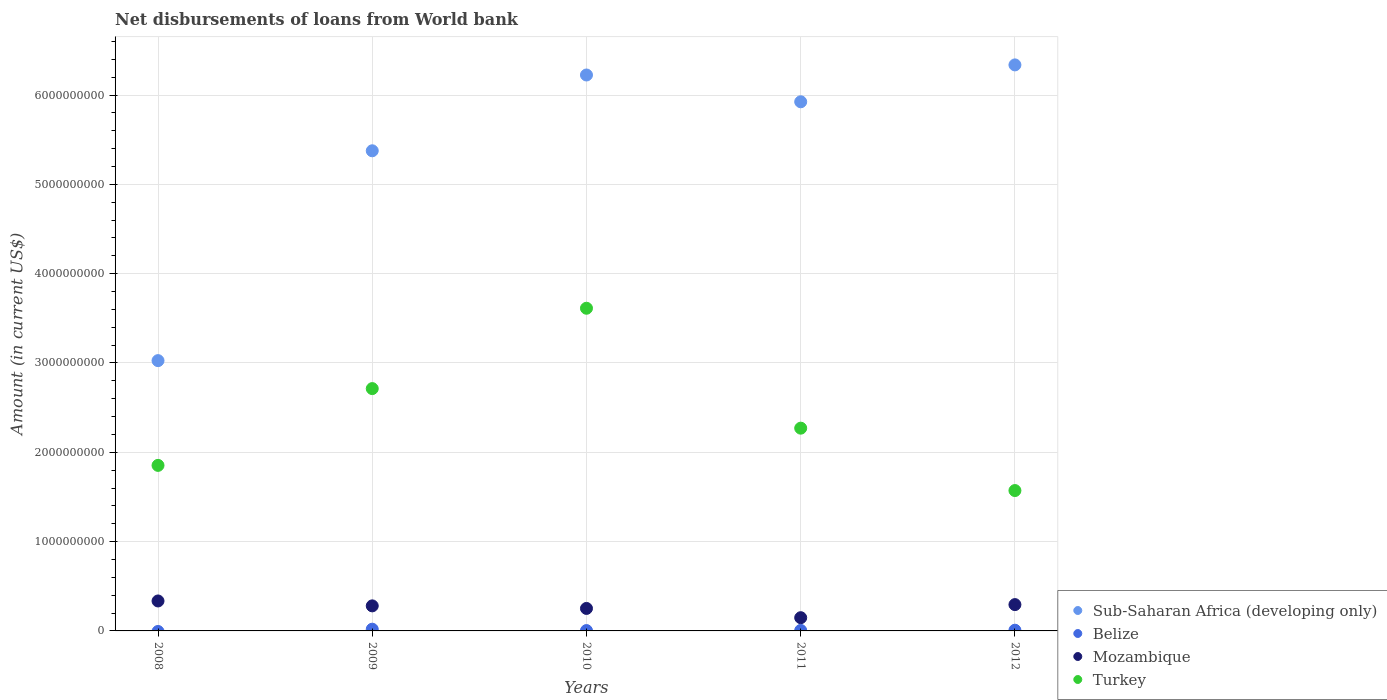How many different coloured dotlines are there?
Ensure brevity in your answer.  4. What is the amount of loan disbursed from World Bank in Turkey in 2012?
Your answer should be very brief. 1.57e+09. Across all years, what is the maximum amount of loan disbursed from World Bank in Belize?
Offer a terse response. 1.93e+07. Across all years, what is the minimum amount of loan disbursed from World Bank in Mozambique?
Provide a short and direct response. 1.48e+08. In which year was the amount of loan disbursed from World Bank in Turkey maximum?
Give a very brief answer. 2010. What is the total amount of loan disbursed from World Bank in Belize in the graph?
Your response must be concise. 3.68e+07. What is the difference between the amount of loan disbursed from World Bank in Mozambique in 2011 and that in 2012?
Keep it short and to the point. -1.47e+08. What is the difference between the amount of loan disbursed from World Bank in Turkey in 2011 and the amount of loan disbursed from World Bank in Mozambique in 2010?
Make the answer very short. 2.02e+09. What is the average amount of loan disbursed from World Bank in Turkey per year?
Make the answer very short. 2.40e+09. In the year 2010, what is the difference between the amount of loan disbursed from World Bank in Mozambique and amount of loan disbursed from World Bank in Sub-Saharan Africa (developing only)?
Provide a succinct answer. -5.97e+09. In how many years, is the amount of loan disbursed from World Bank in Turkey greater than 6000000000 US$?
Your answer should be compact. 0. What is the ratio of the amount of loan disbursed from World Bank in Turkey in 2010 to that in 2011?
Ensure brevity in your answer.  1.59. Is the difference between the amount of loan disbursed from World Bank in Mozambique in 2011 and 2012 greater than the difference between the amount of loan disbursed from World Bank in Sub-Saharan Africa (developing only) in 2011 and 2012?
Keep it short and to the point. Yes. What is the difference between the highest and the second highest amount of loan disbursed from World Bank in Sub-Saharan Africa (developing only)?
Ensure brevity in your answer.  1.13e+08. What is the difference between the highest and the lowest amount of loan disbursed from World Bank in Mozambique?
Offer a terse response. 1.87e+08. Is the sum of the amount of loan disbursed from World Bank in Sub-Saharan Africa (developing only) in 2008 and 2011 greater than the maximum amount of loan disbursed from World Bank in Mozambique across all years?
Give a very brief answer. Yes. Is it the case that in every year, the sum of the amount of loan disbursed from World Bank in Belize and amount of loan disbursed from World Bank in Sub-Saharan Africa (developing only)  is greater than the sum of amount of loan disbursed from World Bank in Mozambique and amount of loan disbursed from World Bank in Turkey?
Offer a very short reply. No. Is it the case that in every year, the sum of the amount of loan disbursed from World Bank in Turkey and amount of loan disbursed from World Bank in Belize  is greater than the amount of loan disbursed from World Bank in Sub-Saharan Africa (developing only)?
Give a very brief answer. No. Does the amount of loan disbursed from World Bank in Sub-Saharan Africa (developing only) monotonically increase over the years?
Give a very brief answer. No. Is the amount of loan disbursed from World Bank in Mozambique strictly greater than the amount of loan disbursed from World Bank in Turkey over the years?
Your answer should be compact. No. Is the amount of loan disbursed from World Bank in Belize strictly less than the amount of loan disbursed from World Bank in Turkey over the years?
Ensure brevity in your answer.  Yes. How many dotlines are there?
Provide a short and direct response. 4. Does the graph contain any zero values?
Offer a terse response. Yes. Where does the legend appear in the graph?
Make the answer very short. Bottom right. What is the title of the graph?
Your answer should be compact. Net disbursements of loans from World bank. What is the label or title of the X-axis?
Your answer should be very brief. Years. What is the label or title of the Y-axis?
Your response must be concise. Amount (in current US$). What is the Amount (in current US$) of Sub-Saharan Africa (developing only) in 2008?
Offer a terse response. 3.03e+09. What is the Amount (in current US$) of Belize in 2008?
Your answer should be compact. 0. What is the Amount (in current US$) in Mozambique in 2008?
Your answer should be very brief. 3.35e+08. What is the Amount (in current US$) of Turkey in 2008?
Provide a succinct answer. 1.85e+09. What is the Amount (in current US$) of Sub-Saharan Africa (developing only) in 2009?
Ensure brevity in your answer.  5.38e+09. What is the Amount (in current US$) of Belize in 2009?
Make the answer very short. 1.93e+07. What is the Amount (in current US$) in Mozambique in 2009?
Offer a terse response. 2.80e+08. What is the Amount (in current US$) of Turkey in 2009?
Provide a short and direct response. 2.71e+09. What is the Amount (in current US$) of Sub-Saharan Africa (developing only) in 2010?
Provide a succinct answer. 6.22e+09. What is the Amount (in current US$) in Belize in 2010?
Ensure brevity in your answer.  3.92e+06. What is the Amount (in current US$) of Mozambique in 2010?
Your answer should be very brief. 2.52e+08. What is the Amount (in current US$) in Turkey in 2010?
Provide a short and direct response. 3.61e+09. What is the Amount (in current US$) of Sub-Saharan Africa (developing only) in 2011?
Provide a succinct answer. 5.92e+09. What is the Amount (in current US$) of Belize in 2011?
Give a very brief answer. 5.65e+06. What is the Amount (in current US$) in Mozambique in 2011?
Provide a short and direct response. 1.48e+08. What is the Amount (in current US$) of Turkey in 2011?
Provide a short and direct response. 2.27e+09. What is the Amount (in current US$) in Sub-Saharan Africa (developing only) in 2012?
Your response must be concise. 6.34e+09. What is the Amount (in current US$) in Belize in 2012?
Ensure brevity in your answer.  7.91e+06. What is the Amount (in current US$) in Mozambique in 2012?
Give a very brief answer. 2.95e+08. What is the Amount (in current US$) in Turkey in 2012?
Offer a terse response. 1.57e+09. Across all years, what is the maximum Amount (in current US$) in Sub-Saharan Africa (developing only)?
Offer a terse response. 6.34e+09. Across all years, what is the maximum Amount (in current US$) of Belize?
Your answer should be compact. 1.93e+07. Across all years, what is the maximum Amount (in current US$) of Mozambique?
Make the answer very short. 3.35e+08. Across all years, what is the maximum Amount (in current US$) in Turkey?
Keep it short and to the point. 3.61e+09. Across all years, what is the minimum Amount (in current US$) in Sub-Saharan Africa (developing only)?
Make the answer very short. 3.03e+09. Across all years, what is the minimum Amount (in current US$) of Belize?
Provide a succinct answer. 0. Across all years, what is the minimum Amount (in current US$) of Mozambique?
Your answer should be very brief. 1.48e+08. Across all years, what is the minimum Amount (in current US$) of Turkey?
Your response must be concise. 1.57e+09. What is the total Amount (in current US$) of Sub-Saharan Africa (developing only) in the graph?
Give a very brief answer. 2.69e+1. What is the total Amount (in current US$) in Belize in the graph?
Keep it short and to the point. 3.68e+07. What is the total Amount (in current US$) in Mozambique in the graph?
Make the answer very short. 1.31e+09. What is the total Amount (in current US$) of Turkey in the graph?
Offer a terse response. 1.20e+1. What is the difference between the Amount (in current US$) in Sub-Saharan Africa (developing only) in 2008 and that in 2009?
Keep it short and to the point. -2.35e+09. What is the difference between the Amount (in current US$) in Mozambique in 2008 and that in 2009?
Provide a short and direct response. 5.49e+07. What is the difference between the Amount (in current US$) in Turkey in 2008 and that in 2009?
Your answer should be very brief. -8.60e+08. What is the difference between the Amount (in current US$) in Sub-Saharan Africa (developing only) in 2008 and that in 2010?
Keep it short and to the point. -3.20e+09. What is the difference between the Amount (in current US$) in Mozambique in 2008 and that in 2010?
Your response must be concise. 8.36e+07. What is the difference between the Amount (in current US$) in Turkey in 2008 and that in 2010?
Make the answer very short. -1.76e+09. What is the difference between the Amount (in current US$) of Sub-Saharan Africa (developing only) in 2008 and that in 2011?
Give a very brief answer. -2.90e+09. What is the difference between the Amount (in current US$) in Mozambique in 2008 and that in 2011?
Provide a succinct answer. 1.87e+08. What is the difference between the Amount (in current US$) of Turkey in 2008 and that in 2011?
Offer a terse response. -4.17e+08. What is the difference between the Amount (in current US$) in Sub-Saharan Africa (developing only) in 2008 and that in 2012?
Your answer should be compact. -3.31e+09. What is the difference between the Amount (in current US$) in Mozambique in 2008 and that in 2012?
Offer a terse response. 4.08e+07. What is the difference between the Amount (in current US$) of Turkey in 2008 and that in 2012?
Keep it short and to the point. 2.82e+08. What is the difference between the Amount (in current US$) in Sub-Saharan Africa (developing only) in 2009 and that in 2010?
Your answer should be compact. -8.49e+08. What is the difference between the Amount (in current US$) of Belize in 2009 and that in 2010?
Make the answer very short. 1.54e+07. What is the difference between the Amount (in current US$) of Mozambique in 2009 and that in 2010?
Ensure brevity in your answer.  2.87e+07. What is the difference between the Amount (in current US$) of Turkey in 2009 and that in 2010?
Offer a very short reply. -9.00e+08. What is the difference between the Amount (in current US$) of Sub-Saharan Africa (developing only) in 2009 and that in 2011?
Make the answer very short. -5.49e+08. What is the difference between the Amount (in current US$) in Belize in 2009 and that in 2011?
Offer a very short reply. 1.37e+07. What is the difference between the Amount (in current US$) of Mozambique in 2009 and that in 2011?
Make the answer very short. 1.32e+08. What is the difference between the Amount (in current US$) of Turkey in 2009 and that in 2011?
Offer a very short reply. 4.43e+08. What is the difference between the Amount (in current US$) of Sub-Saharan Africa (developing only) in 2009 and that in 2012?
Offer a very short reply. -9.62e+08. What is the difference between the Amount (in current US$) of Belize in 2009 and that in 2012?
Make the answer very short. 1.14e+07. What is the difference between the Amount (in current US$) in Mozambique in 2009 and that in 2012?
Ensure brevity in your answer.  -1.42e+07. What is the difference between the Amount (in current US$) in Turkey in 2009 and that in 2012?
Keep it short and to the point. 1.14e+09. What is the difference between the Amount (in current US$) of Sub-Saharan Africa (developing only) in 2010 and that in 2011?
Your answer should be very brief. 3.00e+08. What is the difference between the Amount (in current US$) of Belize in 2010 and that in 2011?
Make the answer very short. -1.73e+06. What is the difference between the Amount (in current US$) of Mozambique in 2010 and that in 2011?
Offer a terse response. 1.04e+08. What is the difference between the Amount (in current US$) in Turkey in 2010 and that in 2011?
Your answer should be very brief. 1.34e+09. What is the difference between the Amount (in current US$) of Sub-Saharan Africa (developing only) in 2010 and that in 2012?
Offer a terse response. -1.13e+08. What is the difference between the Amount (in current US$) in Belize in 2010 and that in 2012?
Ensure brevity in your answer.  -3.98e+06. What is the difference between the Amount (in current US$) of Mozambique in 2010 and that in 2012?
Provide a succinct answer. -4.29e+07. What is the difference between the Amount (in current US$) in Turkey in 2010 and that in 2012?
Provide a short and direct response. 2.04e+09. What is the difference between the Amount (in current US$) in Sub-Saharan Africa (developing only) in 2011 and that in 2012?
Your response must be concise. -4.13e+08. What is the difference between the Amount (in current US$) of Belize in 2011 and that in 2012?
Provide a succinct answer. -2.26e+06. What is the difference between the Amount (in current US$) of Mozambique in 2011 and that in 2012?
Your answer should be compact. -1.47e+08. What is the difference between the Amount (in current US$) in Turkey in 2011 and that in 2012?
Offer a very short reply. 6.99e+08. What is the difference between the Amount (in current US$) in Sub-Saharan Africa (developing only) in 2008 and the Amount (in current US$) in Belize in 2009?
Your response must be concise. 3.01e+09. What is the difference between the Amount (in current US$) of Sub-Saharan Africa (developing only) in 2008 and the Amount (in current US$) of Mozambique in 2009?
Provide a short and direct response. 2.75e+09. What is the difference between the Amount (in current US$) of Sub-Saharan Africa (developing only) in 2008 and the Amount (in current US$) of Turkey in 2009?
Your response must be concise. 3.13e+08. What is the difference between the Amount (in current US$) in Mozambique in 2008 and the Amount (in current US$) in Turkey in 2009?
Provide a succinct answer. -2.38e+09. What is the difference between the Amount (in current US$) in Sub-Saharan Africa (developing only) in 2008 and the Amount (in current US$) in Belize in 2010?
Keep it short and to the point. 3.02e+09. What is the difference between the Amount (in current US$) of Sub-Saharan Africa (developing only) in 2008 and the Amount (in current US$) of Mozambique in 2010?
Your response must be concise. 2.77e+09. What is the difference between the Amount (in current US$) of Sub-Saharan Africa (developing only) in 2008 and the Amount (in current US$) of Turkey in 2010?
Keep it short and to the point. -5.86e+08. What is the difference between the Amount (in current US$) of Mozambique in 2008 and the Amount (in current US$) of Turkey in 2010?
Your answer should be very brief. -3.28e+09. What is the difference between the Amount (in current US$) in Sub-Saharan Africa (developing only) in 2008 and the Amount (in current US$) in Belize in 2011?
Your answer should be very brief. 3.02e+09. What is the difference between the Amount (in current US$) in Sub-Saharan Africa (developing only) in 2008 and the Amount (in current US$) in Mozambique in 2011?
Ensure brevity in your answer.  2.88e+09. What is the difference between the Amount (in current US$) of Sub-Saharan Africa (developing only) in 2008 and the Amount (in current US$) of Turkey in 2011?
Your response must be concise. 7.56e+08. What is the difference between the Amount (in current US$) of Mozambique in 2008 and the Amount (in current US$) of Turkey in 2011?
Keep it short and to the point. -1.93e+09. What is the difference between the Amount (in current US$) of Sub-Saharan Africa (developing only) in 2008 and the Amount (in current US$) of Belize in 2012?
Make the answer very short. 3.02e+09. What is the difference between the Amount (in current US$) of Sub-Saharan Africa (developing only) in 2008 and the Amount (in current US$) of Mozambique in 2012?
Ensure brevity in your answer.  2.73e+09. What is the difference between the Amount (in current US$) of Sub-Saharan Africa (developing only) in 2008 and the Amount (in current US$) of Turkey in 2012?
Provide a short and direct response. 1.45e+09. What is the difference between the Amount (in current US$) of Mozambique in 2008 and the Amount (in current US$) of Turkey in 2012?
Your answer should be very brief. -1.24e+09. What is the difference between the Amount (in current US$) of Sub-Saharan Africa (developing only) in 2009 and the Amount (in current US$) of Belize in 2010?
Your response must be concise. 5.37e+09. What is the difference between the Amount (in current US$) in Sub-Saharan Africa (developing only) in 2009 and the Amount (in current US$) in Mozambique in 2010?
Your response must be concise. 5.12e+09. What is the difference between the Amount (in current US$) of Sub-Saharan Africa (developing only) in 2009 and the Amount (in current US$) of Turkey in 2010?
Offer a terse response. 1.76e+09. What is the difference between the Amount (in current US$) in Belize in 2009 and the Amount (in current US$) in Mozambique in 2010?
Keep it short and to the point. -2.32e+08. What is the difference between the Amount (in current US$) in Belize in 2009 and the Amount (in current US$) in Turkey in 2010?
Your response must be concise. -3.59e+09. What is the difference between the Amount (in current US$) of Mozambique in 2009 and the Amount (in current US$) of Turkey in 2010?
Offer a very short reply. -3.33e+09. What is the difference between the Amount (in current US$) in Sub-Saharan Africa (developing only) in 2009 and the Amount (in current US$) in Belize in 2011?
Your answer should be compact. 5.37e+09. What is the difference between the Amount (in current US$) in Sub-Saharan Africa (developing only) in 2009 and the Amount (in current US$) in Mozambique in 2011?
Provide a short and direct response. 5.23e+09. What is the difference between the Amount (in current US$) in Sub-Saharan Africa (developing only) in 2009 and the Amount (in current US$) in Turkey in 2011?
Give a very brief answer. 3.11e+09. What is the difference between the Amount (in current US$) of Belize in 2009 and the Amount (in current US$) of Mozambique in 2011?
Offer a very short reply. -1.29e+08. What is the difference between the Amount (in current US$) in Belize in 2009 and the Amount (in current US$) in Turkey in 2011?
Make the answer very short. -2.25e+09. What is the difference between the Amount (in current US$) of Mozambique in 2009 and the Amount (in current US$) of Turkey in 2011?
Offer a terse response. -1.99e+09. What is the difference between the Amount (in current US$) in Sub-Saharan Africa (developing only) in 2009 and the Amount (in current US$) in Belize in 2012?
Provide a succinct answer. 5.37e+09. What is the difference between the Amount (in current US$) of Sub-Saharan Africa (developing only) in 2009 and the Amount (in current US$) of Mozambique in 2012?
Your response must be concise. 5.08e+09. What is the difference between the Amount (in current US$) of Sub-Saharan Africa (developing only) in 2009 and the Amount (in current US$) of Turkey in 2012?
Provide a succinct answer. 3.80e+09. What is the difference between the Amount (in current US$) of Belize in 2009 and the Amount (in current US$) of Mozambique in 2012?
Keep it short and to the point. -2.75e+08. What is the difference between the Amount (in current US$) in Belize in 2009 and the Amount (in current US$) in Turkey in 2012?
Give a very brief answer. -1.55e+09. What is the difference between the Amount (in current US$) in Mozambique in 2009 and the Amount (in current US$) in Turkey in 2012?
Provide a short and direct response. -1.29e+09. What is the difference between the Amount (in current US$) in Sub-Saharan Africa (developing only) in 2010 and the Amount (in current US$) in Belize in 2011?
Your response must be concise. 6.22e+09. What is the difference between the Amount (in current US$) of Sub-Saharan Africa (developing only) in 2010 and the Amount (in current US$) of Mozambique in 2011?
Your answer should be compact. 6.08e+09. What is the difference between the Amount (in current US$) in Sub-Saharan Africa (developing only) in 2010 and the Amount (in current US$) in Turkey in 2011?
Make the answer very short. 3.95e+09. What is the difference between the Amount (in current US$) of Belize in 2010 and the Amount (in current US$) of Mozambique in 2011?
Provide a succinct answer. -1.44e+08. What is the difference between the Amount (in current US$) in Belize in 2010 and the Amount (in current US$) in Turkey in 2011?
Give a very brief answer. -2.27e+09. What is the difference between the Amount (in current US$) in Mozambique in 2010 and the Amount (in current US$) in Turkey in 2011?
Offer a terse response. -2.02e+09. What is the difference between the Amount (in current US$) in Sub-Saharan Africa (developing only) in 2010 and the Amount (in current US$) in Belize in 2012?
Your response must be concise. 6.22e+09. What is the difference between the Amount (in current US$) in Sub-Saharan Africa (developing only) in 2010 and the Amount (in current US$) in Mozambique in 2012?
Offer a terse response. 5.93e+09. What is the difference between the Amount (in current US$) in Sub-Saharan Africa (developing only) in 2010 and the Amount (in current US$) in Turkey in 2012?
Offer a terse response. 4.65e+09. What is the difference between the Amount (in current US$) in Belize in 2010 and the Amount (in current US$) in Mozambique in 2012?
Ensure brevity in your answer.  -2.91e+08. What is the difference between the Amount (in current US$) in Belize in 2010 and the Amount (in current US$) in Turkey in 2012?
Give a very brief answer. -1.57e+09. What is the difference between the Amount (in current US$) in Mozambique in 2010 and the Amount (in current US$) in Turkey in 2012?
Provide a short and direct response. -1.32e+09. What is the difference between the Amount (in current US$) of Sub-Saharan Africa (developing only) in 2011 and the Amount (in current US$) of Belize in 2012?
Give a very brief answer. 5.92e+09. What is the difference between the Amount (in current US$) of Sub-Saharan Africa (developing only) in 2011 and the Amount (in current US$) of Mozambique in 2012?
Offer a terse response. 5.63e+09. What is the difference between the Amount (in current US$) of Sub-Saharan Africa (developing only) in 2011 and the Amount (in current US$) of Turkey in 2012?
Provide a succinct answer. 4.35e+09. What is the difference between the Amount (in current US$) in Belize in 2011 and the Amount (in current US$) in Mozambique in 2012?
Keep it short and to the point. -2.89e+08. What is the difference between the Amount (in current US$) of Belize in 2011 and the Amount (in current US$) of Turkey in 2012?
Your response must be concise. -1.57e+09. What is the difference between the Amount (in current US$) in Mozambique in 2011 and the Amount (in current US$) in Turkey in 2012?
Provide a short and direct response. -1.42e+09. What is the average Amount (in current US$) of Sub-Saharan Africa (developing only) per year?
Your answer should be very brief. 5.38e+09. What is the average Amount (in current US$) of Belize per year?
Your response must be concise. 7.36e+06. What is the average Amount (in current US$) of Mozambique per year?
Ensure brevity in your answer.  2.62e+08. What is the average Amount (in current US$) of Turkey per year?
Provide a short and direct response. 2.40e+09. In the year 2008, what is the difference between the Amount (in current US$) in Sub-Saharan Africa (developing only) and Amount (in current US$) in Mozambique?
Your response must be concise. 2.69e+09. In the year 2008, what is the difference between the Amount (in current US$) of Sub-Saharan Africa (developing only) and Amount (in current US$) of Turkey?
Provide a succinct answer. 1.17e+09. In the year 2008, what is the difference between the Amount (in current US$) in Mozambique and Amount (in current US$) in Turkey?
Ensure brevity in your answer.  -1.52e+09. In the year 2009, what is the difference between the Amount (in current US$) in Sub-Saharan Africa (developing only) and Amount (in current US$) in Belize?
Your response must be concise. 5.36e+09. In the year 2009, what is the difference between the Amount (in current US$) in Sub-Saharan Africa (developing only) and Amount (in current US$) in Mozambique?
Keep it short and to the point. 5.10e+09. In the year 2009, what is the difference between the Amount (in current US$) in Sub-Saharan Africa (developing only) and Amount (in current US$) in Turkey?
Your answer should be very brief. 2.66e+09. In the year 2009, what is the difference between the Amount (in current US$) of Belize and Amount (in current US$) of Mozambique?
Ensure brevity in your answer.  -2.61e+08. In the year 2009, what is the difference between the Amount (in current US$) of Belize and Amount (in current US$) of Turkey?
Provide a succinct answer. -2.69e+09. In the year 2009, what is the difference between the Amount (in current US$) in Mozambique and Amount (in current US$) in Turkey?
Make the answer very short. -2.43e+09. In the year 2010, what is the difference between the Amount (in current US$) in Sub-Saharan Africa (developing only) and Amount (in current US$) in Belize?
Your answer should be compact. 6.22e+09. In the year 2010, what is the difference between the Amount (in current US$) of Sub-Saharan Africa (developing only) and Amount (in current US$) of Mozambique?
Your answer should be compact. 5.97e+09. In the year 2010, what is the difference between the Amount (in current US$) of Sub-Saharan Africa (developing only) and Amount (in current US$) of Turkey?
Provide a short and direct response. 2.61e+09. In the year 2010, what is the difference between the Amount (in current US$) in Belize and Amount (in current US$) in Mozambique?
Ensure brevity in your answer.  -2.48e+08. In the year 2010, what is the difference between the Amount (in current US$) of Belize and Amount (in current US$) of Turkey?
Your response must be concise. -3.61e+09. In the year 2010, what is the difference between the Amount (in current US$) in Mozambique and Amount (in current US$) in Turkey?
Your response must be concise. -3.36e+09. In the year 2011, what is the difference between the Amount (in current US$) of Sub-Saharan Africa (developing only) and Amount (in current US$) of Belize?
Your response must be concise. 5.92e+09. In the year 2011, what is the difference between the Amount (in current US$) in Sub-Saharan Africa (developing only) and Amount (in current US$) in Mozambique?
Your answer should be very brief. 5.78e+09. In the year 2011, what is the difference between the Amount (in current US$) in Sub-Saharan Africa (developing only) and Amount (in current US$) in Turkey?
Your answer should be very brief. 3.65e+09. In the year 2011, what is the difference between the Amount (in current US$) of Belize and Amount (in current US$) of Mozambique?
Offer a terse response. -1.42e+08. In the year 2011, what is the difference between the Amount (in current US$) of Belize and Amount (in current US$) of Turkey?
Ensure brevity in your answer.  -2.26e+09. In the year 2011, what is the difference between the Amount (in current US$) in Mozambique and Amount (in current US$) in Turkey?
Offer a very short reply. -2.12e+09. In the year 2012, what is the difference between the Amount (in current US$) in Sub-Saharan Africa (developing only) and Amount (in current US$) in Belize?
Your response must be concise. 6.33e+09. In the year 2012, what is the difference between the Amount (in current US$) of Sub-Saharan Africa (developing only) and Amount (in current US$) of Mozambique?
Your answer should be compact. 6.04e+09. In the year 2012, what is the difference between the Amount (in current US$) of Sub-Saharan Africa (developing only) and Amount (in current US$) of Turkey?
Offer a terse response. 4.77e+09. In the year 2012, what is the difference between the Amount (in current US$) of Belize and Amount (in current US$) of Mozambique?
Give a very brief answer. -2.87e+08. In the year 2012, what is the difference between the Amount (in current US$) of Belize and Amount (in current US$) of Turkey?
Keep it short and to the point. -1.56e+09. In the year 2012, what is the difference between the Amount (in current US$) of Mozambique and Amount (in current US$) of Turkey?
Offer a very short reply. -1.28e+09. What is the ratio of the Amount (in current US$) in Sub-Saharan Africa (developing only) in 2008 to that in 2009?
Make the answer very short. 0.56. What is the ratio of the Amount (in current US$) in Mozambique in 2008 to that in 2009?
Make the answer very short. 1.2. What is the ratio of the Amount (in current US$) of Turkey in 2008 to that in 2009?
Provide a succinct answer. 0.68. What is the ratio of the Amount (in current US$) in Sub-Saharan Africa (developing only) in 2008 to that in 2010?
Offer a terse response. 0.49. What is the ratio of the Amount (in current US$) of Mozambique in 2008 to that in 2010?
Your answer should be very brief. 1.33. What is the ratio of the Amount (in current US$) of Turkey in 2008 to that in 2010?
Keep it short and to the point. 0.51. What is the ratio of the Amount (in current US$) of Sub-Saharan Africa (developing only) in 2008 to that in 2011?
Ensure brevity in your answer.  0.51. What is the ratio of the Amount (in current US$) in Mozambique in 2008 to that in 2011?
Provide a succinct answer. 2.27. What is the ratio of the Amount (in current US$) of Turkey in 2008 to that in 2011?
Provide a succinct answer. 0.82. What is the ratio of the Amount (in current US$) in Sub-Saharan Africa (developing only) in 2008 to that in 2012?
Ensure brevity in your answer.  0.48. What is the ratio of the Amount (in current US$) in Mozambique in 2008 to that in 2012?
Your response must be concise. 1.14. What is the ratio of the Amount (in current US$) in Turkey in 2008 to that in 2012?
Give a very brief answer. 1.18. What is the ratio of the Amount (in current US$) of Sub-Saharan Africa (developing only) in 2009 to that in 2010?
Provide a short and direct response. 0.86. What is the ratio of the Amount (in current US$) of Belize in 2009 to that in 2010?
Your answer should be very brief. 4.92. What is the ratio of the Amount (in current US$) of Mozambique in 2009 to that in 2010?
Provide a short and direct response. 1.11. What is the ratio of the Amount (in current US$) in Turkey in 2009 to that in 2010?
Your answer should be very brief. 0.75. What is the ratio of the Amount (in current US$) of Sub-Saharan Africa (developing only) in 2009 to that in 2011?
Provide a short and direct response. 0.91. What is the ratio of the Amount (in current US$) of Belize in 2009 to that in 2011?
Provide a short and direct response. 3.42. What is the ratio of the Amount (in current US$) of Mozambique in 2009 to that in 2011?
Offer a very short reply. 1.89. What is the ratio of the Amount (in current US$) of Turkey in 2009 to that in 2011?
Your response must be concise. 1.2. What is the ratio of the Amount (in current US$) of Sub-Saharan Africa (developing only) in 2009 to that in 2012?
Offer a very short reply. 0.85. What is the ratio of the Amount (in current US$) of Belize in 2009 to that in 2012?
Make the answer very short. 2.44. What is the ratio of the Amount (in current US$) in Mozambique in 2009 to that in 2012?
Offer a very short reply. 0.95. What is the ratio of the Amount (in current US$) of Turkey in 2009 to that in 2012?
Your response must be concise. 1.73. What is the ratio of the Amount (in current US$) of Sub-Saharan Africa (developing only) in 2010 to that in 2011?
Offer a very short reply. 1.05. What is the ratio of the Amount (in current US$) of Belize in 2010 to that in 2011?
Give a very brief answer. 0.69. What is the ratio of the Amount (in current US$) of Mozambique in 2010 to that in 2011?
Ensure brevity in your answer.  1.7. What is the ratio of the Amount (in current US$) in Turkey in 2010 to that in 2011?
Your answer should be compact. 1.59. What is the ratio of the Amount (in current US$) in Sub-Saharan Africa (developing only) in 2010 to that in 2012?
Your answer should be compact. 0.98. What is the ratio of the Amount (in current US$) of Belize in 2010 to that in 2012?
Give a very brief answer. 0.5. What is the ratio of the Amount (in current US$) of Mozambique in 2010 to that in 2012?
Make the answer very short. 0.85. What is the ratio of the Amount (in current US$) of Turkey in 2010 to that in 2012?
Your response must be concise. 2.3. What is the ratio of the Amount (in current US$) of Sub-Saharan Africa (developing only) in 2011 to that in 2012?
Give a very brief answer. 0.93. What is the ratio of the Amount (in current US$) of Belize in 2011 to that in 2012?
Provide a succinct answer. 0.71. What is the ratio of the Amount (in current US$) of Mozambique in 2011 to that in 2012?
Make the answer very short. 0.5. What is the ratio of the Amount (in current US$) in Turkey in 2011 to that in 2012?
Your response must be concise. 1.44. What is the difference between the highest and the second highest Amount (in current US$) of Sub-Saharan Africa (developing only)?
Your answer should be compact. 1.13e+08. What is the difference between the highest and the second highest Amount (in current US$) of Belize?
Offer a terse response. 1.14e+07. What is the difference between the highest and the second highest Amount (in current US$) in Mozambique?
Keep it short and to the point. 4.08e+07. What is the difference between the highest and the second highest Amount (in current US$) of Turkey?
Your response must be concise. 9.00e+08. What is the difference between the highest and the lowest Amount (in current US$) of Sub-Saharan Africa (developing only)?
Ensure brevity in your answer.  3.31e+09. What is the difference between the highest and the lowest Amount (in current US$) in Belize?
Offer a terse response. 1.93e+07. What is the difference between the highest and the lowest Amount (in current US$) in Mozambique?
Your answer should be compact. 1.87e+08. What is the difference between the highest and the lowest Amount (in current US$) in Turkey?
Offer a terse response. 2.04e+09. 